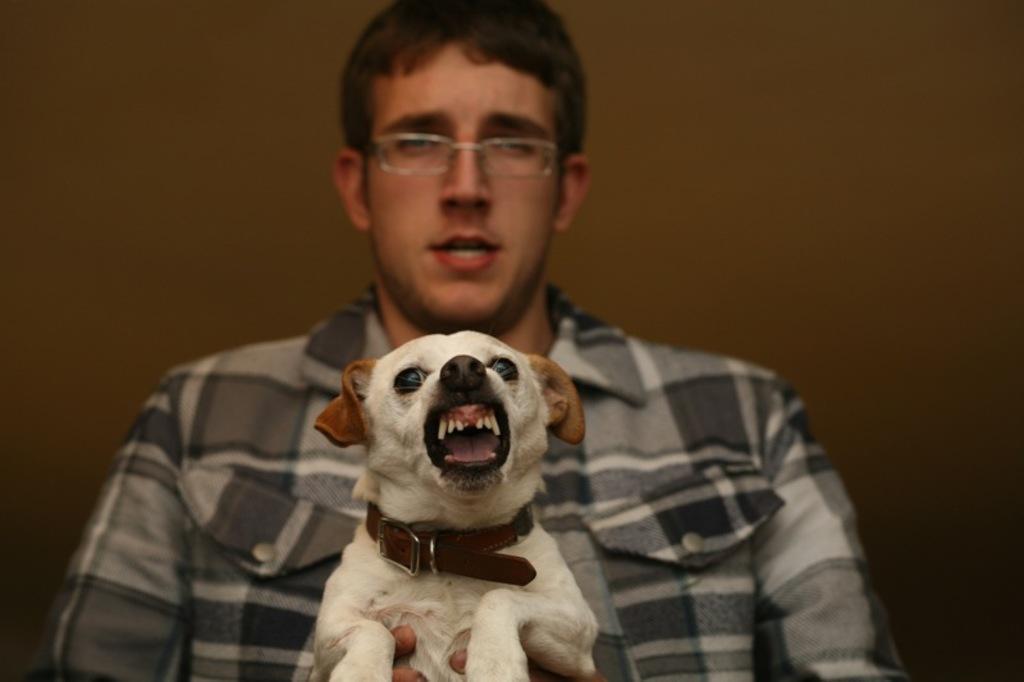Could you give a brief overview of what you see in this image? in the picture we can see a person holding a dog with a belt on around its neck. 